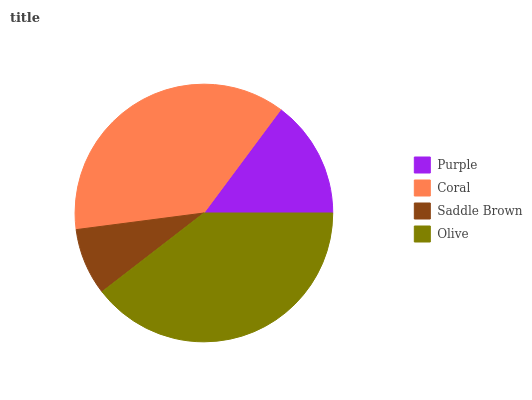Is Saddle Brown the minimum?
Answer yes or no. Yes. Is Olive the maximum?
Answer yes or no. Yes. Is Coral the minimum?
Answer yes or no. No. Is Coral the maximum?
Answer yes or no. No. Is Coral greater than Purple?
Answer yes or no. Yes. Is Purple less than Coral?
Answer yes or no. Yes. Is Purple greater than Coral?
Answer yes or no. No. Is Coral less than Purple?
Answer yes or no. No. Is Coral the high median?
Answer yes or no. Yes. Is Purple the low median?
Answer yes or no. Yes. Is Purple the high median?
Answer yes or no. No. Is Coral the low median?
Answer yes or no. No. 